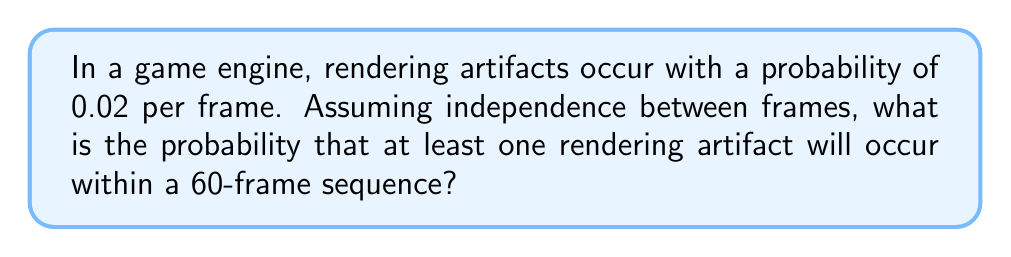Solve this math problem. To solve this problem, we'll follow these steps:

1) First, let's consider the probability of no artifacts occurring in a single frame. This is the complement of the probability of an artifact occurring:

   $P(\text{no artifact in one frame}) = 1 - 0.02 = 0.98$

2) For the entire 60-frame sequence to be artifact-free, each frame must be artifact-free. Assuming independence, we multiply these probabilities:

   $P(\text{no artifacts in 60 frames}) = (0.98)^{60}$

3) Now, the probability of at least one artifact occurring is the complement of the probability of no artifacts occurring:

   $P(\text{at least one artifact in 60 frames}) = 1 - P(\text{no artifacts in 60 frames})$

4) Let's calculate this:

   $P(\text{at least one artifact in 60 frames}) = 1 - (0.98)^{60}$

5) Using a calculator or computer:

   $(0.98)^{60} \approx 0.2976$

6) Therefore:

   $P(\text{at least one artifact in 60 frames}) = 1 - 0.2976 = 0.7024$

This means there's approximately a 70.24% chance of encountering at least one rendering artifact in a 60-frame sequence.
Answer: The probability of at least one rendering artifact occurring within a 60-frame sequence is approximately 0.7024 or 70.24%. 